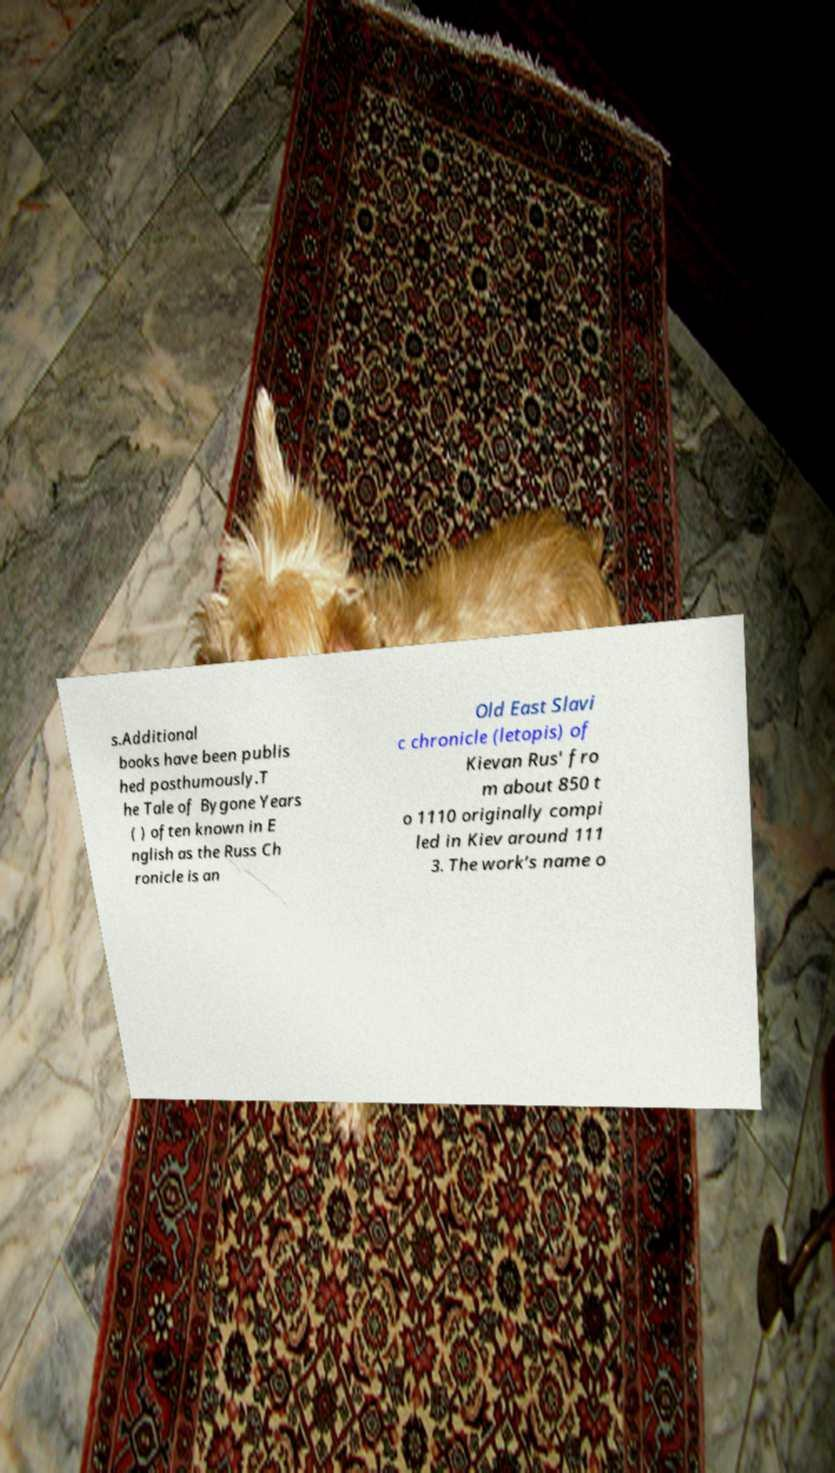Please read and relay the text visible in this image. What does it say? s.Additional books have been publis hed posthumously.T he Tale of Bygone Years ( ) often known in E nglish as the Russ Ch ronicle is an Old East Slavi c chronicle (letopis) of Kievan Rus' fro m about 850 t o 1110 originally compi led in Kiev around 111 3. The work’s name o 